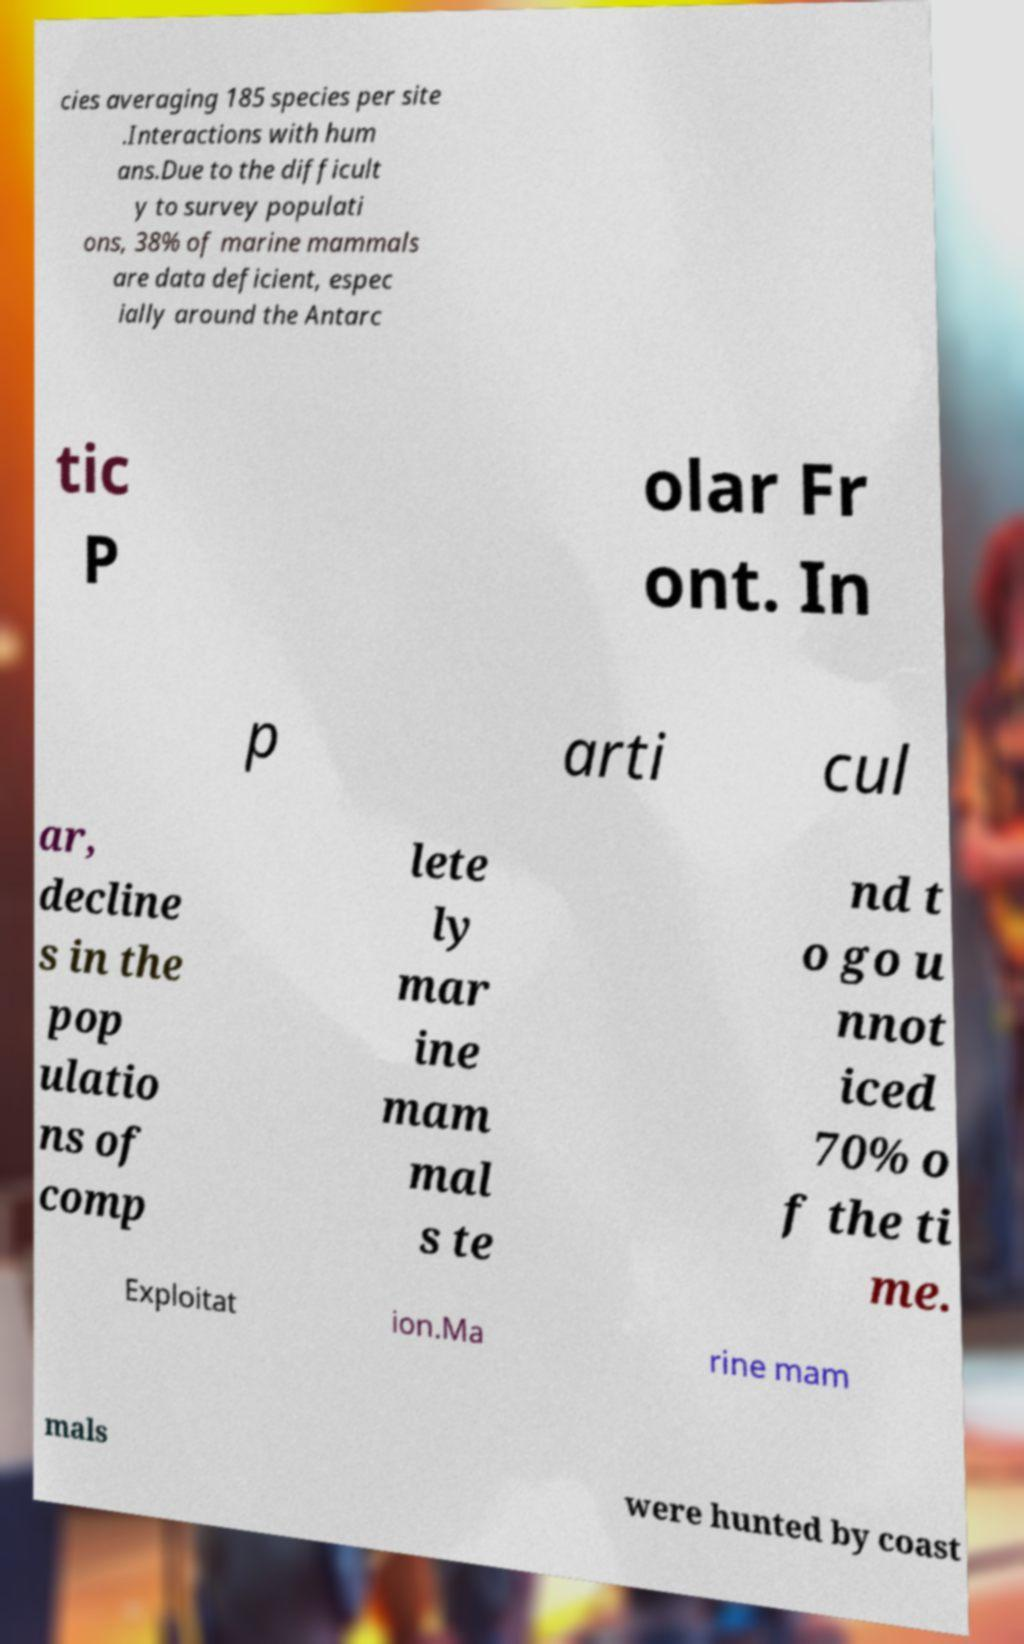Can you accurately transcribe the text from the provided image for me? cies averaging 185 species per site .Interactions with hum ans.Due to the difficult y to survey populati ons, 38% of marine mammals are data deficient, espec ially around the Antarc tic P olar Fr ont. In p arti cul ar, decline s in the pop ulatio ns of comp lete ly mar ine mam mal s te nd t o go u nnot iced 70% o f the ti me. Exploitat ion.Ma rine mam mals were hunted by coast 